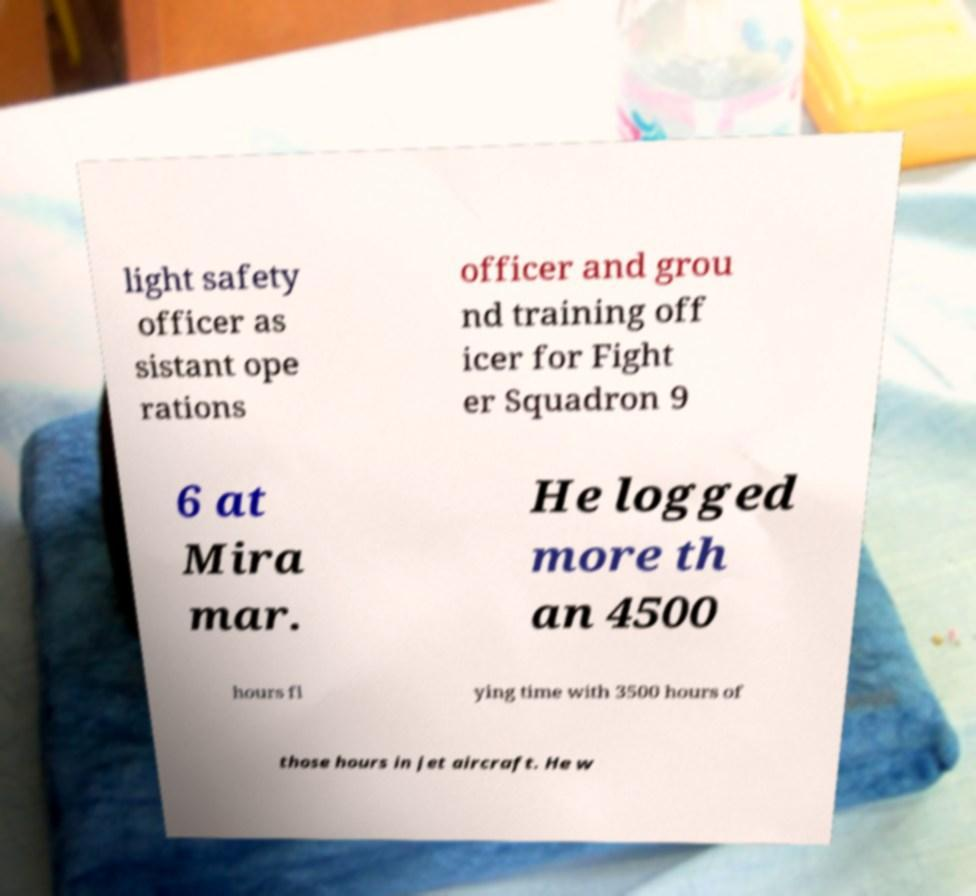Can you read and provide the text displayed in the image?This photo seems to have some interesting text. Can you extract and type it out for me? light safety officer as sistant ope rations officer and grou nd training off icer for Fight er Squadron 9 6 at Mira mar. He logged more th an 4500 hours fl ying time with 3500 hours of those hours in jet aircraft. He w 